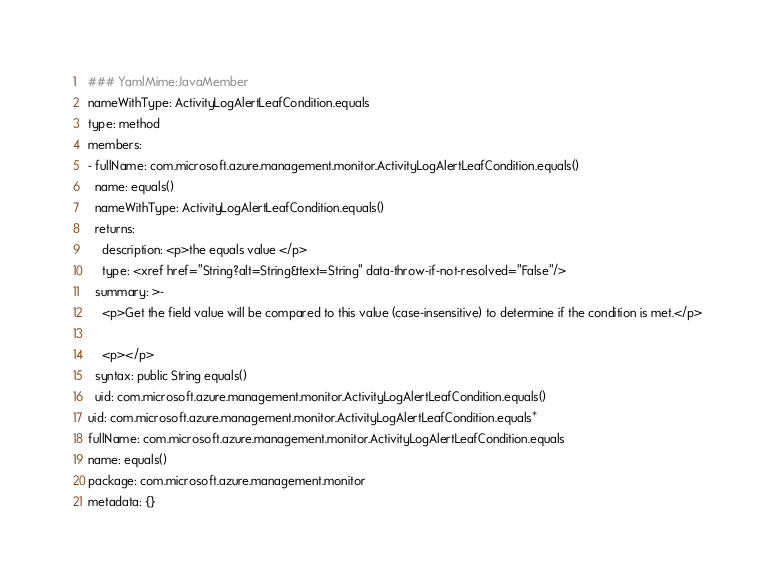Convert code to text. <code><loc_0><loc_0><loc_500><loc_500><_YAML_>### YamlMime:JavaMember
nameWithType: ActivityLogAlertLeafCondition.equals
type: method
members:
- fullName: com.microsoft.azure.management.monitor.ActivityLogAlertLeafCondition.equals()
  name: equals()
  nameWithType: ActivityLogAlertLeafCondition.equals()
  returns:
    description: <p>the equals value </p>
    type: <xref href="String?alt=String&text=String" data-throw-if-not-resolved="False"/>
  summary: >-
    <p>Get the field value will be compared to this value (case-insensitive) to determine if the condition is met.</p>

    <p></p>
  syntax: public String equals()
  uid: com.microsoft.azure.management.monitor.ActivityLogAlertLeafCondition.equals()
uid: com.microsoft.azure.management.monitor.ActivityLogAlertLeafCondition.equals*
fullName: com.microsoft.azure.management.monitor.ActivityLogAlertLeafCondition.equals
name: equals()
package: com.microsoft.azure.management.monitor
metadata: {}
</code> 